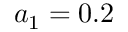<formula> <loc_0><loc_0><loc_500><loc_500>a _ { 1 } = 0 . 2</formula> 